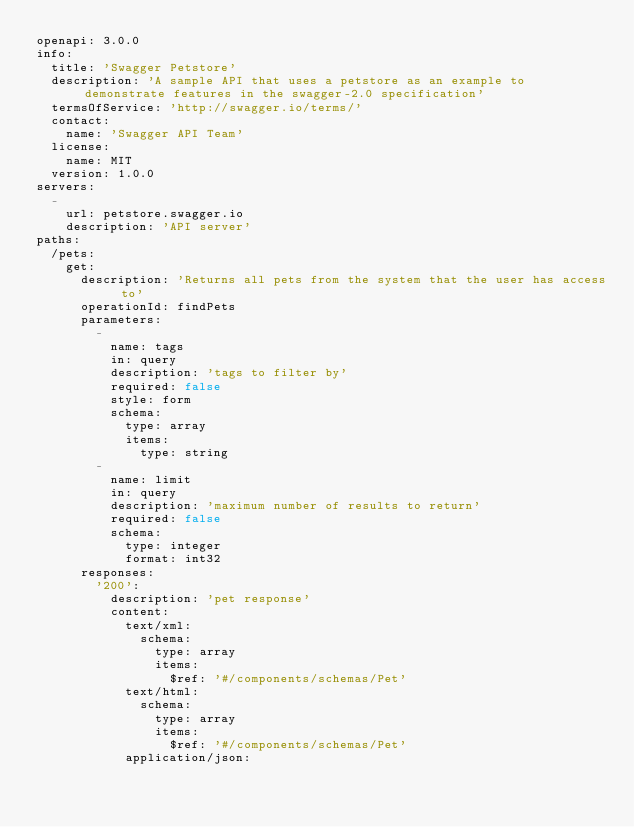<code> <loc_0><loc_0><loc_500><loc_500><_YAML_>openapi: 3.0.0
info:
  title: 'Swagger Petstore'
  description: 'A sample API that uses a petstore as an example to demonstrate features in the swagger-2.0 specification'
  termsOfService: 'http://swagger.io/terms/'
  contact:
    name: 'Swagger API Team'
  license:
    name: MIT
  version: 1.0.0
servers:
  -
    url: petstore.swagger.io
    description: 'API server'
paths:
  /pets:
    get:
      description: 'Returns all pets from the system that the user has access to'
      operationId: findPets
      parameters:
        -
          name: tags
          in: query
          description: 'tags to filter by'
          required: false
          style: form
          schema:
            type: array
            items:
              type: string
        -
          name: limit
          in: query
          description: 'maximum number of results to return'
          required: false
          schema:
            type: integer
            format: int32
      responses:
        '200':
          description: 'pet response'
          content:
            text/xml:
              schema:
                type: array
                items:
                  $ref: '#/components/schemas/Pet'
            text/html:
              schema:
                type: array
                items:
                  $ref: '#/components/schemas/Pet'
            application/json:</code> 